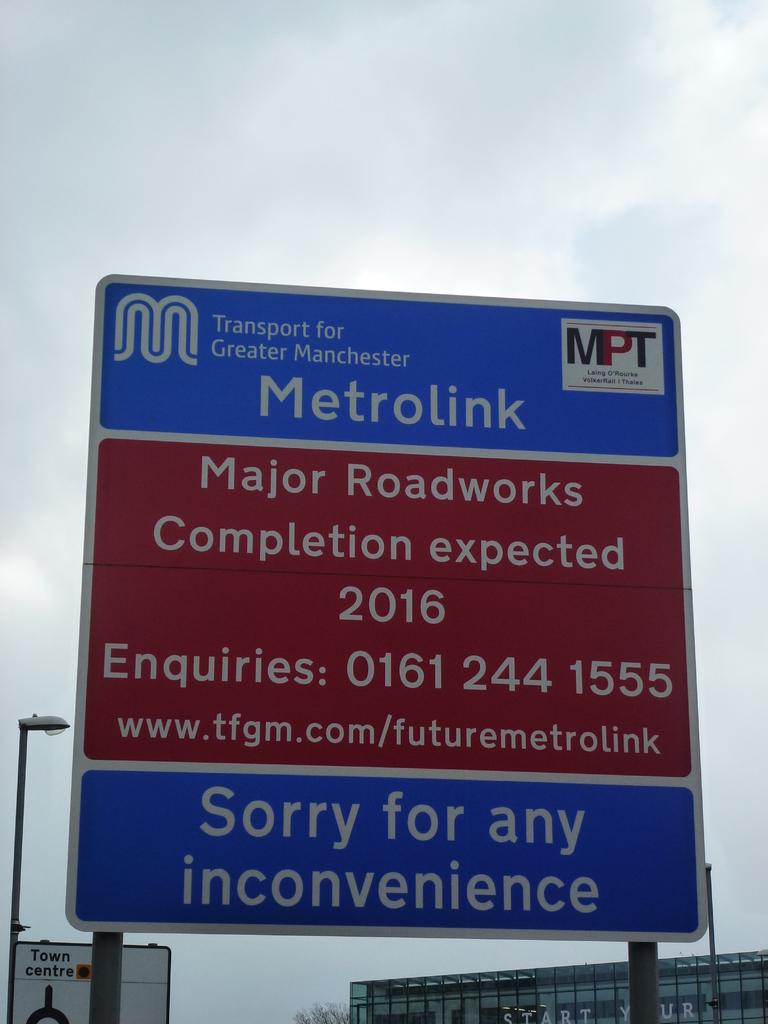<image>
Summarize the visual content of the image. A sign announces the timeframe for roadwork in Manchester. 